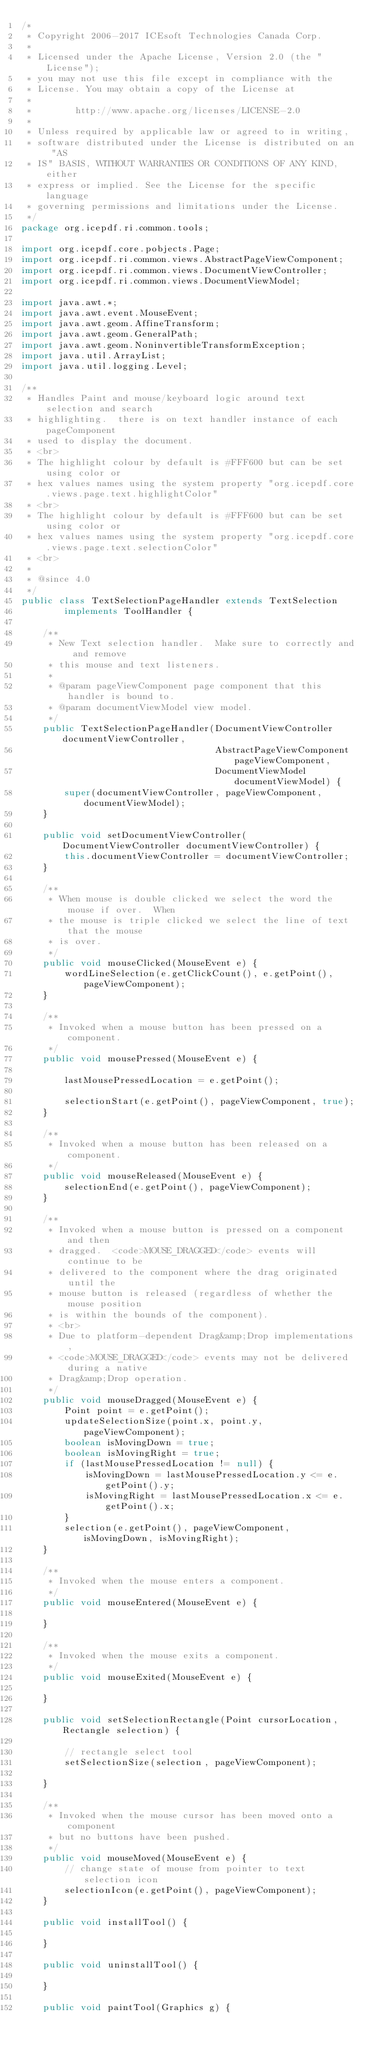<code> <loc_0><loc_0><loc_500><loc_500><_Java_>/*
 * Copyright 2006-2017 ICEsoft Technologies Canada Corp.
 *
 * Licensed under the Apache License, Version 2.0 (the "License");
 * you may not use this file except in compliance with the
 * License. You may obtain a copy of the License at
 *
 *        http://www.apache.org/licenses/LICENSE-2.0
 *
 * Unless required by applicable law or agreed to in writing,
 * software distributed under the License is distributed on an "AS
 * IS" BASIS, WITHOUT WARRANTIES OR CONDITIONS OF ANY KIND, either
 * express or implied. See the License for the specific language
 * governing permissions and limitations under the License.
 */
package org.icepdf.ri.common.tools;

import org.icepdf.core.pobjects.Page;
import org.icepdf.ri.common.views.AbstractPageViewComponent;
import org.icepdf.ri.common.views.DocumentViewController;
import org.icepdf.ri.common.views.DocumentViewModel;

import java.awt.*;
import java.awt.event.MouseEvent;
import java.awt.geom.AffineTransform;
import java.awt.geom.GeneralPath;
import java.awt.geom.NoninvertibleTransformException;
import java.util.ArrayList;
import java.util.logging.Level;

/**
 * Handles Paint and mouse/keyboard logic around text selection and search
 * highlighting.  there is on text handler instance of each pageComponent
 * used to display the document.
 * <br>
 * The highlight colour by default is #FFF600 but can be set using color or
 * hex values names using the system property "org.icepdf.core.views.page.text.highlightColor"
 * <br>
 * The highlight colour by default is #FFF600 but can be set using color or
 * hex values names using the system property "org.icepdf.core.views.page.text.selectionColor"
 * <br>
 *
 * @since 4.0
 */
public class TextSelectionPageHandler extends TextSelection
        implements ToolHandler {

    /**
     * New Text selection handler.  Make sure to correctly and and remove
     * this mouse and text listeners.
     *
     * @param pageViewComponent page component that this handler is bound to.
     * @param documentViewModel view model.
     */
    public TextSelectionPageHandler(DocumentViewController documentViewController,
                                    AbstractPageViewComponent pageViewComponent,
                                    DocumentViewModel documentViewModel) {
        super(documentViewController, pageViewComponent, documentViewModel);
    }

    public void setDocumentViewController(DocumentViewController documentViewController) {
        this.documentViewController = documentViewController;
    }

    /**
     * When mouse is double clicked we select the word the mouse if over.  When
     * the mouse is triple clicked we select the line of text that the mouse
     * is over.
     */
    public void mouseClicked(MouseEvent e) {
        wordLineSelection(e.getClickCount(), e.getPoint(), pageViewComponent);
    }

    /**
     * Invoked when a mouse button has been pressed on a component.
     */
    public void mousePressed(MouseEvent e) {

        lastMousePressedLocation = e.getPoint();

        selectionStart(e.getPoint(), pageViewComponent, true);
    }

    /**
     * Invoked when a mouse button has been released on a component.
     */
    public void mouseReleased(MouseEvent e) {
        selectionEnd(e.getPoint(), pageViewComponent);
    }

    /**
     * Invoked when a mouse button is pressed on a component and then
     * dragged.  <code>MOUSE_DRAGGED</code> events will continue to be
     * delivered to the component where the drag originated until the
     * mouse button is released (regardless of whether the mouse position
     * is within the bounds of the component).
     * <br>
     * Due to platform-dependent Drag&amp;Drop implementations,
     * <code>MOUSE_DRAGGED</code> events may not be delivered during a native
     * Drag&amp;Drop operation.
     */
    public void mouseDragged(MouseEvent e) {
        Point point = e.getPoint();
        updateSelectionSize(point.x, point.y, pageViewComponent);
        boolean isMovingDown = true;
        boolean isMovingRight = true;
        if (lastMousePressedLocation != null) {
            isMovingDown = lastMousePressedLocation.y <= e.getPoint().y;
            isMovingRight = lastMousePressedLocation.x <= e.getPoint().x;
        }
        selection(e.getPoint(), pageViewComponent, isMovingDown, isMovingRight);
    }

    /**
     * Invoked when the mouse enters a component.
     */
    public void mouseEntered(MouseEvent e) {

    }

    /**
     * Invoked when the mouse exits a component.
     */
    public void mouseExited(MouseEvent e) {

    }

    public void setSelectionRectangle(Point cursorLocation, Rectangle selection) {

        // rectangle select tool
        setSelectionSize(selection, pageViewComponent);

    }

    /**
     * Invoked when the mouse cursor has been moved onto a component
     * but no buttons have been pushed.
     */
    public void mouseMoved(MouseEvent e) {
        // change state of mouse from pointer to text selection icon
        selectionIcon(e.getPoint(), pageViewComponent);
    }

    public void installTool() {

    }

    public void uninstallTool() {

    }

    public void paintTool(Graphics g) {</code> 